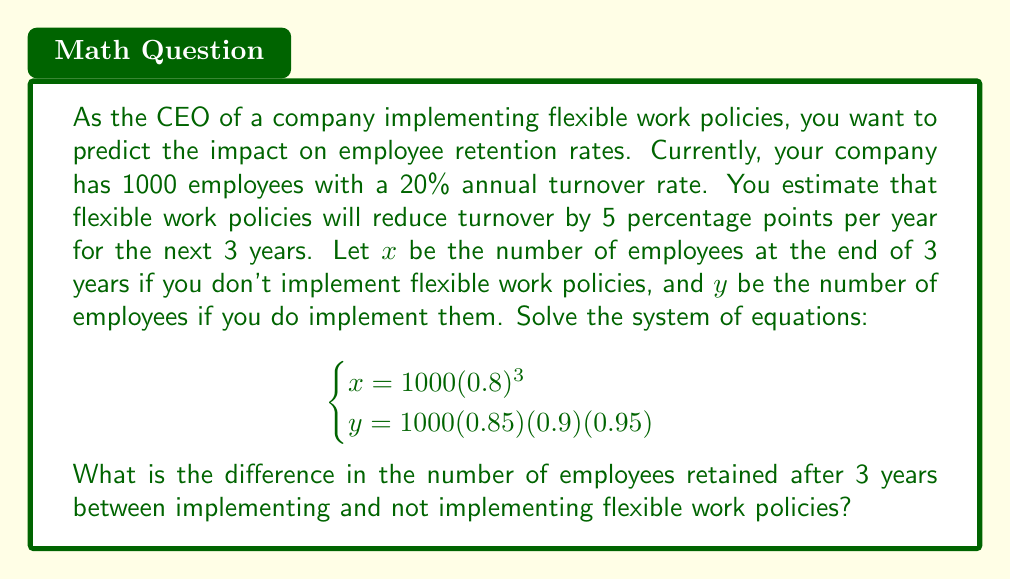Help me with this question. Let's solve this system of equations step by step:

1. For $x$ (without flexible work policies):
   $$x = 1000(0.8)^3$$
   $$x = 1000 \times 0.512 = 512$$

2. For $y$ (with flexible work policies):
   $$y = 1000(0.85)(0.9)(0.95)$$
   $$y = 1000 \times 0.72675 = 726.75$$

3. To find the difference in retained employees, we subtract $x$ from $y$:
   $$\text{Difference} = y - x = 726.75 - 512 = 214.75$$

4. Since we're dealing with whole employees, we round to the nearest integer:
   $$\text{Difference} \approx 215$$

Therefore, implementing flexible work policies would result in retaining approximately 215 more employees after 3 years compared to not implementing such policies.
Answer: 215 employees 